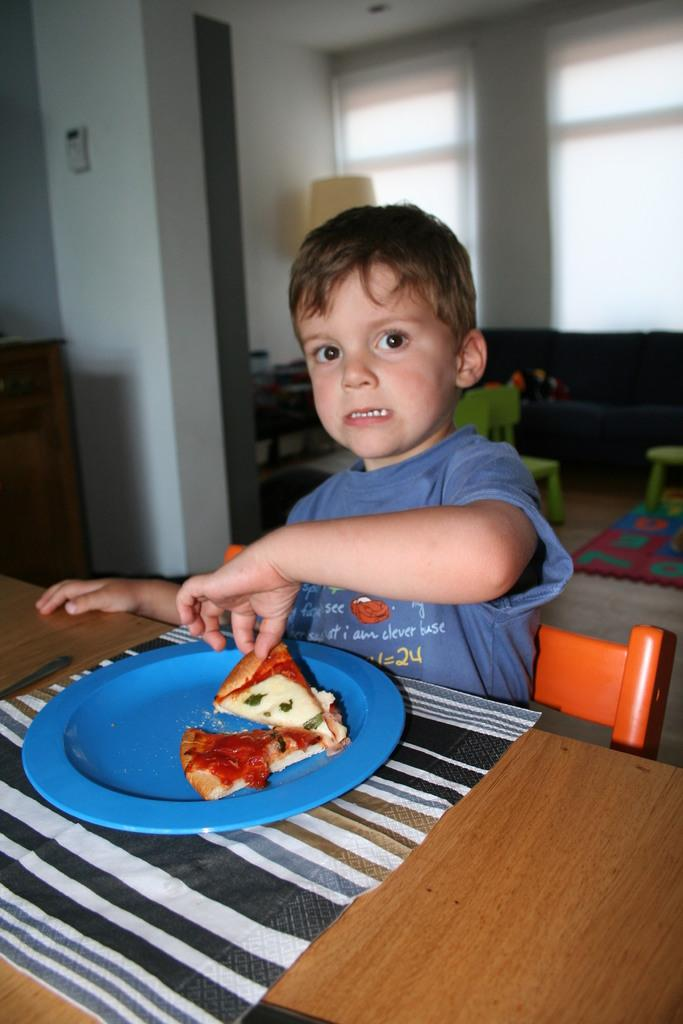What is the person in the image doing? The person is sitting on a chair in the image. What is the person holding? The person is holding food in the image. What is on the table in the image? There is a plate, a mat, food, a spoon, and a glass window in the background on the table. What is the background of the image? The background of the image includes a wall, chairs, and a glass window. What type of surface is the person sitting on? This is the floor. What is the name of the flower on the table in the image? There is no flower present on the table in the image. 